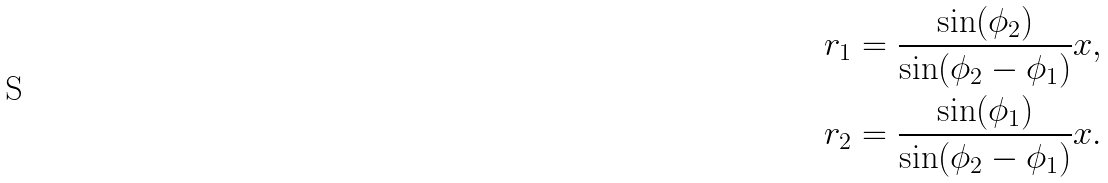<formula> <loc_0><loc_0><loc_500><loc_500>& r _ { 1 } = \frac { \sin ( \phi _ { 2 } ) } { \sin ( \phi _ { 2 } - \phi _ { 1 } ) } x , \\ & r _ { 2 } = \frac { \sin ( \phi _ { 1 } ) } { \sin ( \phi _ { 2 } - \phi _ { 1 } ) } x .</formula> 